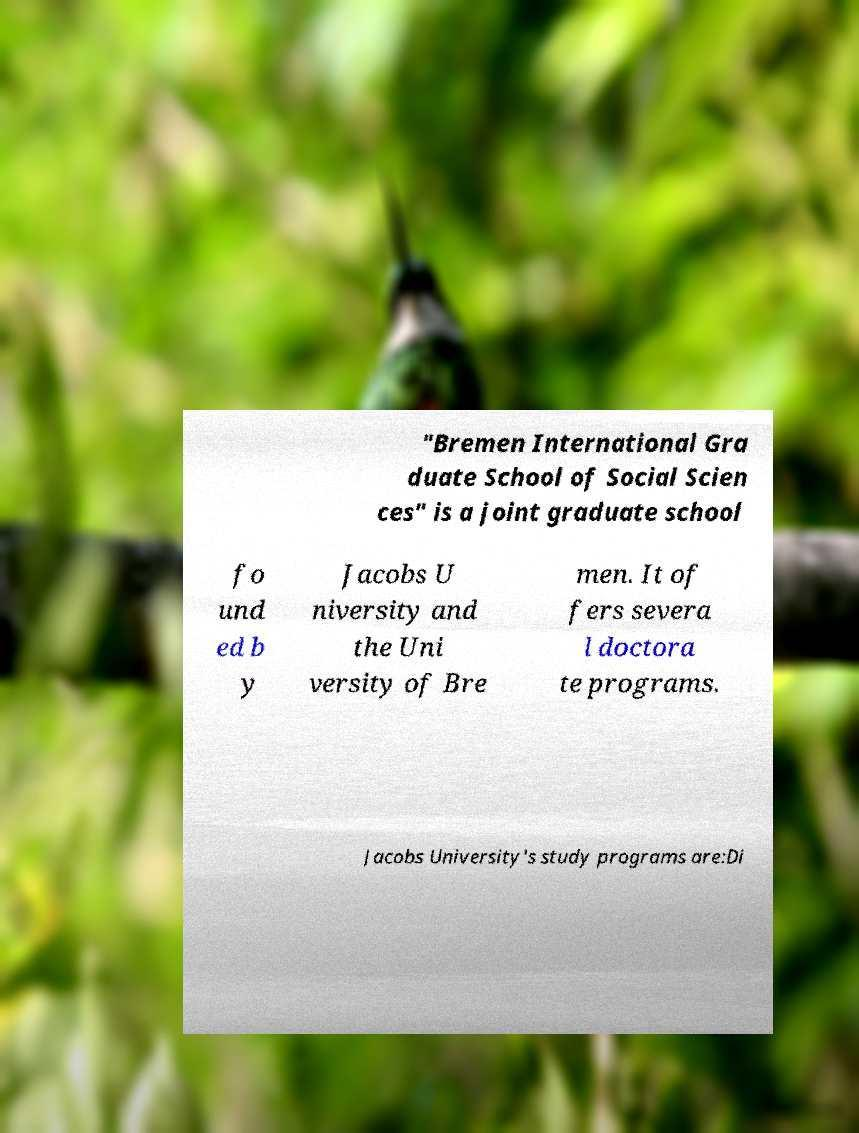Could you extract and type out the text from this image? "Bremen International Gra duate School of Social Scien ces" is a joint graduate school fo und ed b y Jacobs U niversity and the Uni versity of Bre men. It of fers severa l doctora te programs. Jacobs University's study programs are:Di 